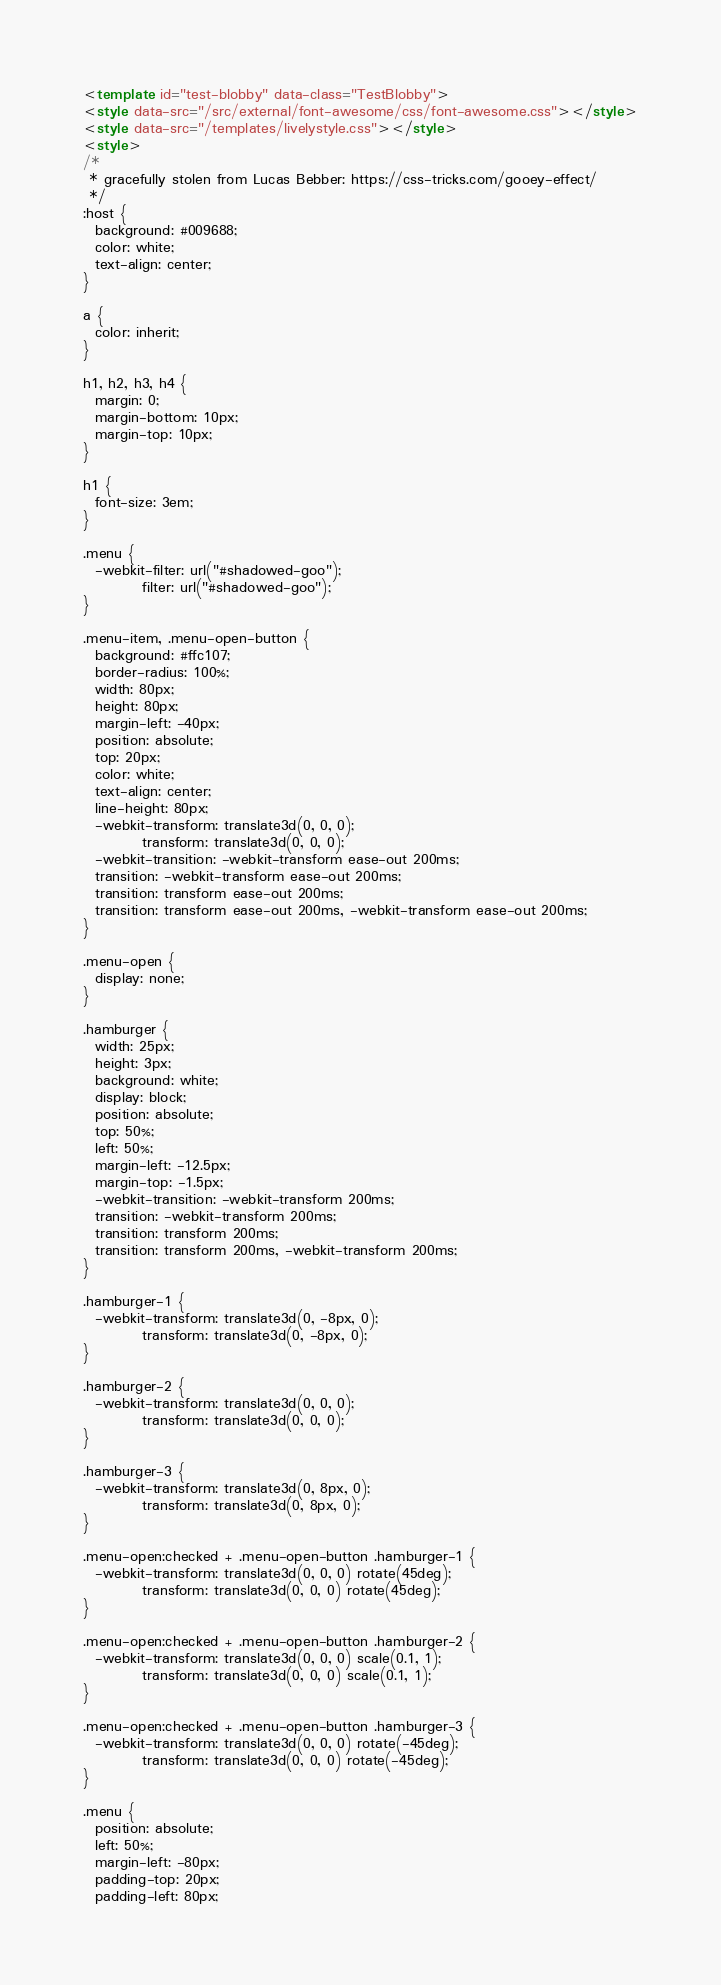<code> <loc_0><loc_0><loc_500><loc_500><_HTML_><template id="test-blobby" data-class="TestBlobby">
<style data-src="/src/external/font-awesome/css/font-awesome.css"></style>
<style data-src="/templates/livelystyle.css"></style>
<style>
/*
 * gracefully stolen from Lucas Bebber: https://css-tricks.com/gooey-effect/
 */
:host {
  background: #009688;
  color: white;
  text-align: center;
}

a {
  color: inherit;
}

h1, h2, h3, h4 {
  margin: 0;
  margin-bottom: 10px;
  margin-top: 10px;
}

h1 {
  font-size: 3em;
}

.menu {
  -webkit-filter: url("#shadowed-goo");
          filter: url("#shadowed-goo");
}

.menu-item, .menu-open-button {
  background: #ffc107;
  border-radius: 100%;
  width: 80px;
  height: 80px;
  margin-left: -40px;
  position: absolute;
  top: 20px;
  color: white;
  text-align: center;
  line-height: 80px;
  -webkit-transform: translate3d(0, 0, 0);
          transform: translate3d(0, 0, 0);
  -webkit-transition: -webkit-transform ease-out 200ms;
  transition: -webkit-transform ease-out 200ms;
  transition: transform ease-out 200ms;
  transition: transform ease-out 200ms, -webkit-transform ease-out 200ms;
}

.menu-open {
  display: none;
}

.hamburger {
  width: 25px;
  height: 3px;
  background: white;
  display: block;
  position: absolute;
  top: 50%;
  left: 50%;
  margin-left: -12.5px;
  margin-top: -1.5px;
  -webkit-transition: -webkit-transform 200ms;
  transition: -webkit-transform 200ms;
  transition: transform 200ms;
  transition: transform 200ms, -webkit-transform 200ms;
}

.hamburger-1 {
  -webkit-transform: translate3d(0, -8px, 0);
          transform: translate3d(0, -8px, 0);
}

.hamburger-2 {
  -webkit-transform: translate3d(0, 0, 0);
          transform: translate3d(0, 0, 0);
}

.hamburger-3 {
  -webkit-transform: translate3d(0, 8px, 0);
          transform: translate3d(0, 8px, 0);
}

.menu-open:checked + .menu-open-button .hamburger-1 {
  -webkit-transform: translate3d(0, 0, 0) rotate(45deg);
          transform: translate3d(0, 0, 0) rotate(45deg);
}

.menu-open:checked + .menu-open-button .hamburger-2 {
  -webkit-transform: translate3d(0, 0, 0) scale(0.1, 1);
          transform: translate3d(0, 0, 0) scale(0.1, 1);
}

.menu-open:checked + .menu-open-button .hamburger-3 {
  -webkit-transform: translate3d(0, 0, 0) rotate(-45deg);
          transform: translate3d(0, 0, 0) rotate(-45deg);
}

.menu {
  position: absolute;
  left: 50%;
  margin-left: -80px;
  padding-top: 20px;
  padding-left: 80px;</code> 